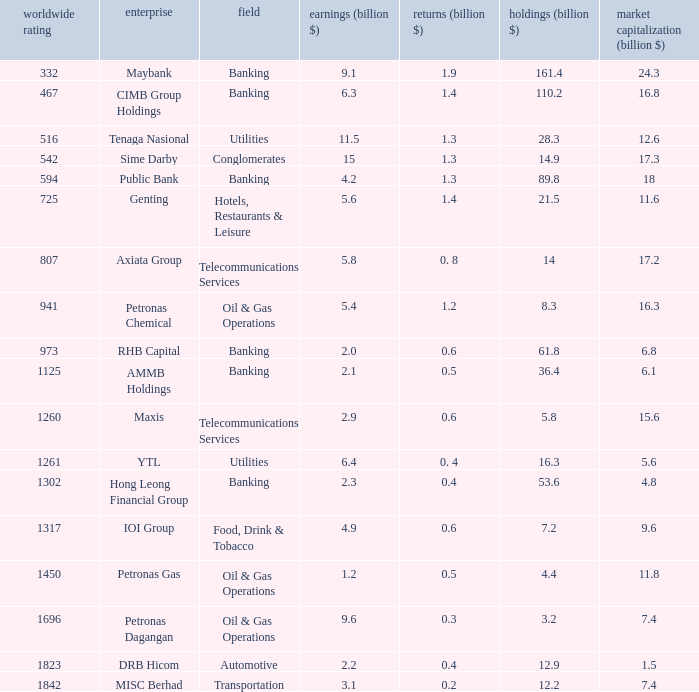1 earnings. Banking. 